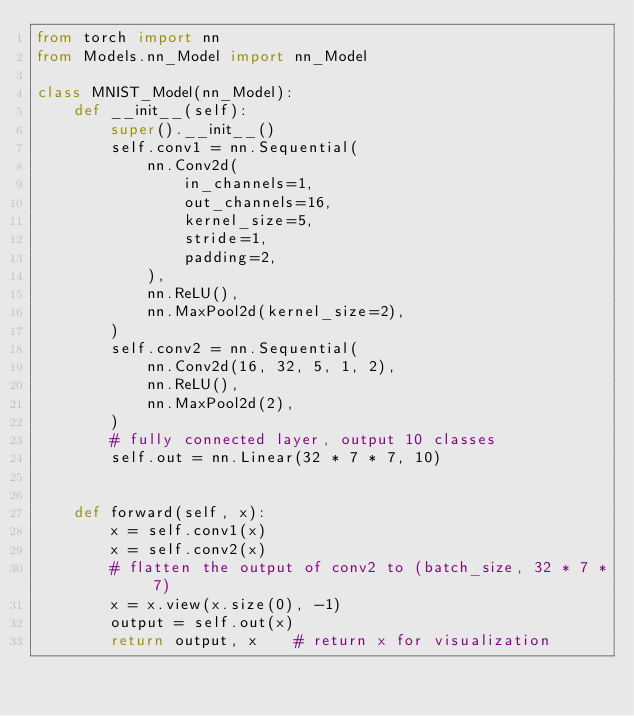<code> <loc_0><loc_0><loc_500><loc_500><_Python_>from torch import nn
from Models.nn_Model import nn_Model

class MNIST_Model(nn_Model):
    def __init__(self):
        super().__init__()
        self.conv1 = nn.Sequential(
            nn.Conv2d(
                in_channels=1,
                out_channels=16,
                kernel_size=5,
                stride=1,
                padding=2,
            ),
            nn.ReLU(),
            nn.MaxPool2d(kernel_size=2),
        )
        self.conv2 = nn.Sequential(
            nn.Conv2d(16, 32, 5, 1, 2),
            nn.ReLU(),
            nn.MaxPool2d(2),
        )
        # fully connected layer, output 10 classes
        self.out = nn.Linear(32 * 7 * 7, 10)


    def forward(self, x):
        x = self.conv1(x)
        x = self.conv2(x)
        # flatten the output of conv2 to (batch_size, 32 * 7 * 7)
        x = x.view(x.size(0), -1)
        output = self.out(x)
        return output, x    # return x for visualization
</code> 